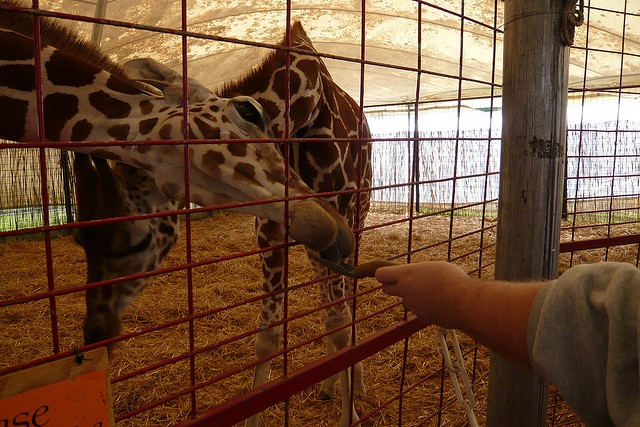Describe the objects in this image and their specific colors. I can see giraffe in maroon, black, and gray tones, giraffe in maroon, black, and olive tones, and people in maroon, black, and brown tones in this image. 